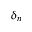Convert formula to latex. <formula><loc_0><loc_0><loc_500><loc_500>\delta _ { n }</formula> 